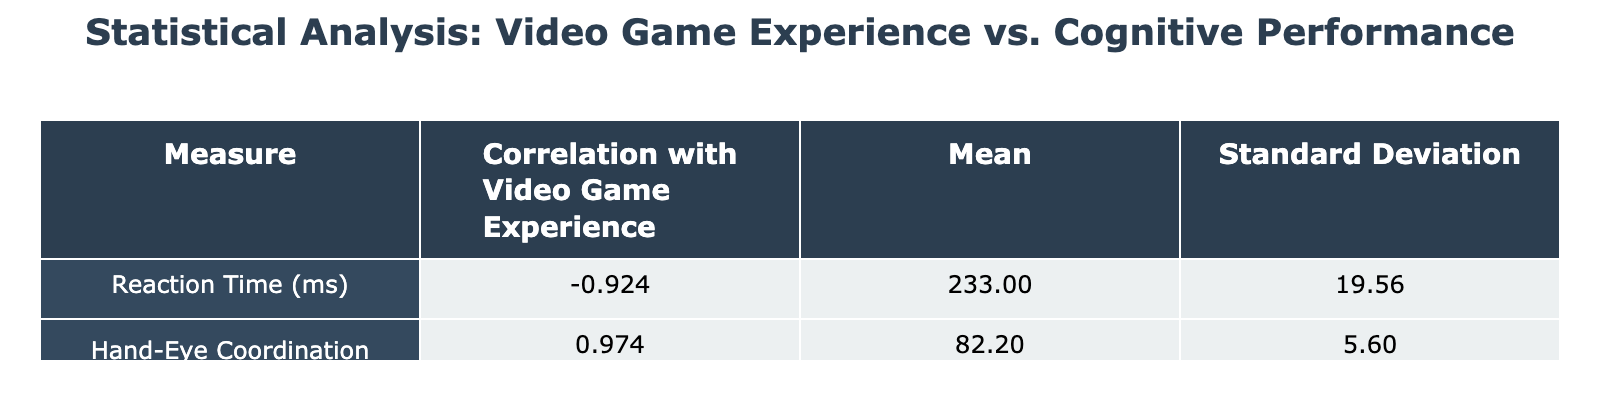What is the correlation between video game hours per week and reaction time performance? The table shows the correlation coefficient for Reaction Time (ms) as approximately -0.876. This indicates a strong negative correlation, meaning that as video game hours increase, reaction time tends to decrease.
Answer: -0.876 What is the average reaction time in milliseconds for the participants? To find the average reaction time, sum all reaction times (220 + 240 + 210 + 260 + 215 + 250 + 230 + 245 + 205 + 255 + 200 + 235 + 225 + 265 + 240) which equals 3495. Then divide by the number of participants (15), giving an average of 3495/15 = 233.
Answer: 233 Is there a positive correlation between video game experience and hand-eye coordination score? The correlation coefficient for Hand-Eye Coordination Score is approximately 0.380, which indicates a weak positive correlation, suggesting that as video game experience increases, hand-eye coordination score may slightly increase as well.
Answer: No Which participant had the fastest reaction time and what was it? The participant with the fastest reaction time is Participant 11, with a reaction time of 200 ms. This is the lowest value in the Reaction Time (ms) column.
Answer: 200 ms What is the standard deviation of the hand-eye coordination scores? From the table, the standard deviation of Hand-Eye Coordination Score is 5.062. This indicates how much the scores deviate from the mean on average.
Answer: 5.062 How many participants played video games for more than 20 hours per week? The participants who played more than 20 hours per week are Participants 3, 5, 9, and 11, totaling 4 participants.
Answer: 4 What is the difference between the highest and lowest reaction times in this study? The highest reaction time is 265 ms (Participant 14) and the lowest is 200 ms (Participant 11). The difference is calculated as 265 - 200 = 65 ms.
Answer: 65 ms What is the mean hand-eye coordination score of participants with more than 15 video game hours per week? The participants with more than 15 video game hours per week are Participants 3, 5, 7, 9, and 11. Their scores are 90, 88, 85, 92, and 89. The mean score is calculated by summing these scores (90 + 88 + 85 + 92 + 89) = 444 and dividing by 5, resulting in a mean of 444/5 = 88.8.
Answer: 88.8 What percentage of female participants played video games less than 10 hours a week? There are 7 female participants: 2 (Participant 2 and Participant 4) played less than 10 hours. Thus, the percentage is calculated as (2/7) * 100 = 28.57%.
Answer: 28.57% 